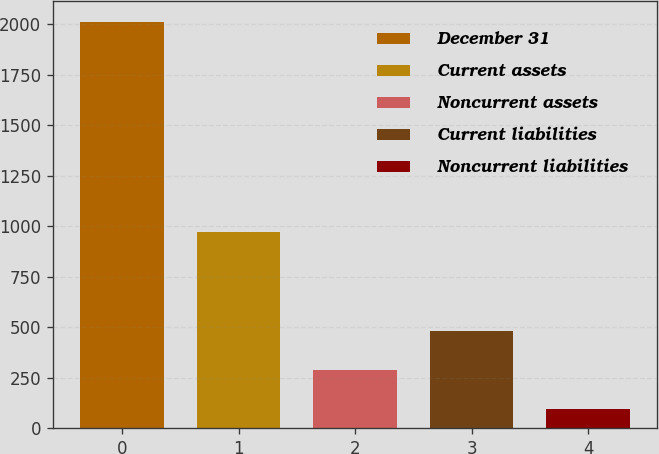<chart> <loc_0><loc_0><loc_500><loc_500><bar_chart><fcel>December 31<fcel>Current assets<fcel>Noncurrent assets<fcel>Current liabilities<fcel>Noncurrent liabilities<nl><fcel>2012<fcel>971<fcel>288.5<fcel>480<fcel>97<nl></chart> 